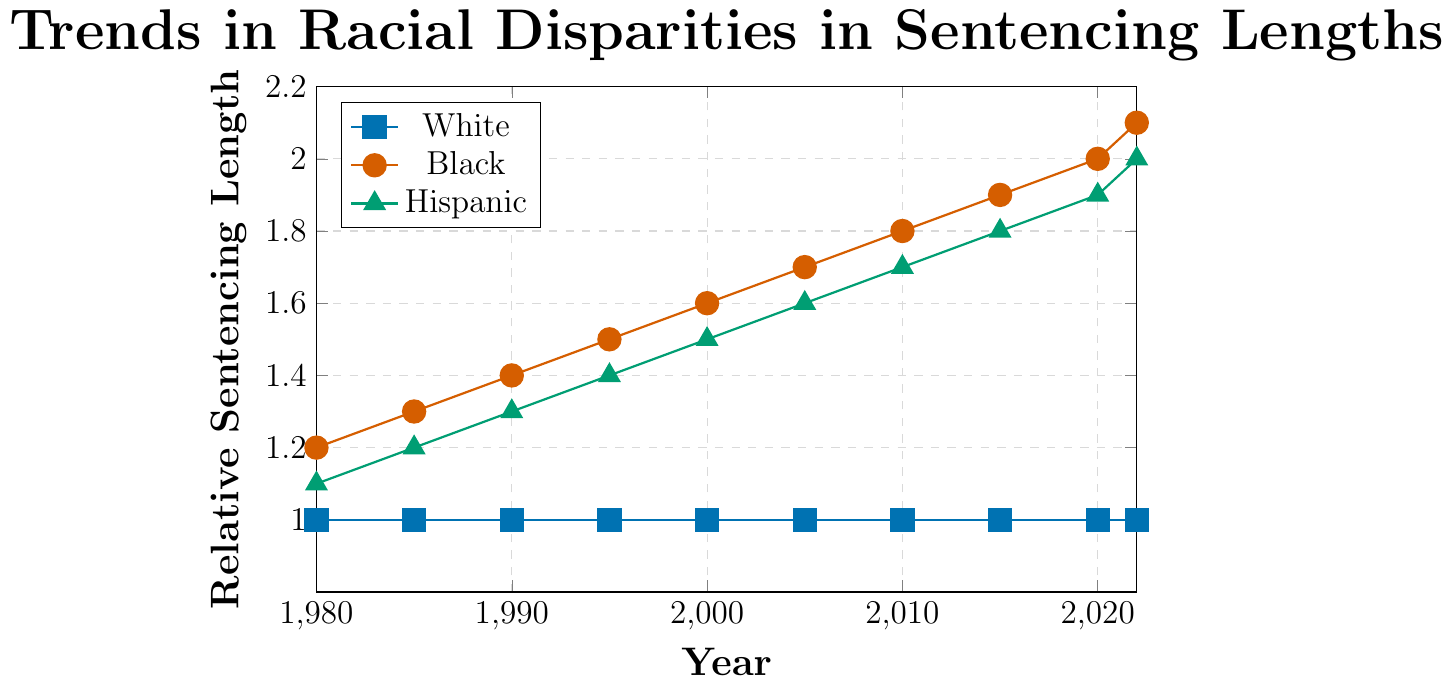Which racial group consistently experiences the shortest relative sentencing lengths over the years? The chart shows three lines corresponding to White, Black, and Hispanic racial groups. The line for White individuals remains consistently at a relative sentencing length of 1.0 throughout the given years, indicating the shortest sentences.
Answer: White How has the relative sentencing length for Black individuals changed from 1980 to 2022? From the chart, the relative sentencing length for Black individuals increased from 1.2 in 1980 to 2.1 in 2022. This demonstrates a clear increasing trend over time.
Answer: Increased What is the relative difference in sentencing length between Black and Hispanic individuals in 2000? In 2000, the chart indicates that the relative sentencing length for Black individuals is 1.6, while for Hispanic individuals it is 1.5. Subtracting the two values: 1.6 - 1.5 = 0.1.
Answer: 0.1 Between which two consecutive years did the relative sentencing length for Hispanic individuals increase the most? Looking at the chart, the increments between years for Hispanic individuals are equal (0.1). To find the largest increase, we need to observe the consistent intervals (1980-1985, 1985-1990, etc.). Since all are equal at 0.1, the increase is the same between each pair of consecutive years.
Answer: All consecutive years What trend can be observed in the relative sentencing length for White individuals from 1980 to 2022? The chart shows that the relative sentencing length for White individuals remains constant at 1.0 throughout the years from 1980 to 2022.
Answer: Constant In what year do Black individuals surpass a relative sentencing length of 2.0? The chart illustrates that the relative sentencing length for Black individuals reaches 2.0 in 2020 and surpasses it, reaching 2.1 in 2022.
Answer: 2022 Compare the relative sentencing lengths for Black and Hispanic individuals in 2022. Which group has a higher value and by how much? In 2022, the relative sentencing length for Black individuals is 2.1 and for Hispanic individuals is 2.0. The difference is 2.1 - 2.0 = 0.1, indicating that Black individuals have a higher value by 0.1.
Answer: Black, by 0.1 What is the overall trend in racial disparities in sentencing lengths from 1980 to 2022? By examining the lines for Black and Hispanic individuals, both show an increasing trend in sentencing lengths over the years. The line for White individuals remains flat at 1.0, highlighting a growing disparity.
Answer: Increasing disparity 